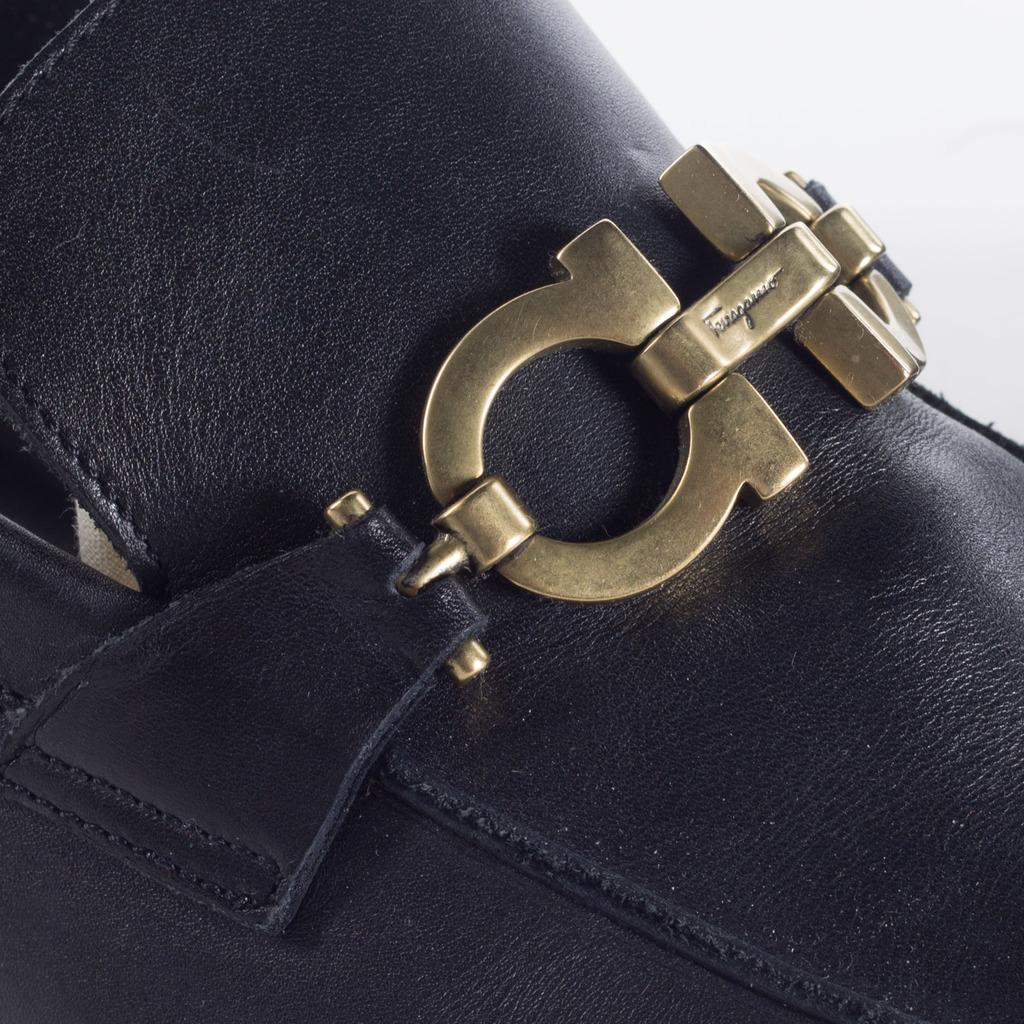What type of material is the main object in the image made of? The main object in the image is made of leather. What is attached to the leather object? There is a metal belt attached to the leather object. What type of sticks can be seen in the image? There are no sticks present in the image. What type of drug is visible in the image? There is no drug present in the image. 